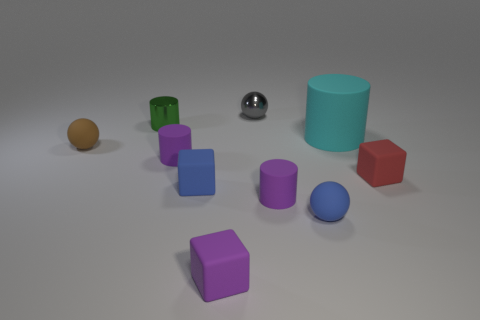Does the cyan cylinder have the same size as the purple cube?
Offer a very short reply. No. Are the tiny cylinder that is behind the large cyan thing and the cube that is to the right of the large cyan cylinder made of the same material?
Keep it short and to the point. No. There is a metallic object in front of the tiny metallic object that is right of the blue thing to the left of the small blue ball; what shape is it?
Offer a terse response. Cylinder. Is the number of large red cylinders greater than the number of green metal cylinders?
Your response must be concise. No. Are there any big green matte blocks?
Offer a very short reply. No. How many things are either rubber objects in front of the small red matte block or spheres behind the large cyan cylinder?
Offer a terse response. 5. Is the metal cylinder the same color as the tiny shiny sphere?
Your answer should be very brief. No. Are there fewer purple cylinders than small cylinders?
Keep it short and to the point. Yes. There is a gray metal sphere; are there any gray things right of it?
Give a very brief answer. No. Do the blue sphere and the gray thing have the same material?
Provide a succinct answer. No. 